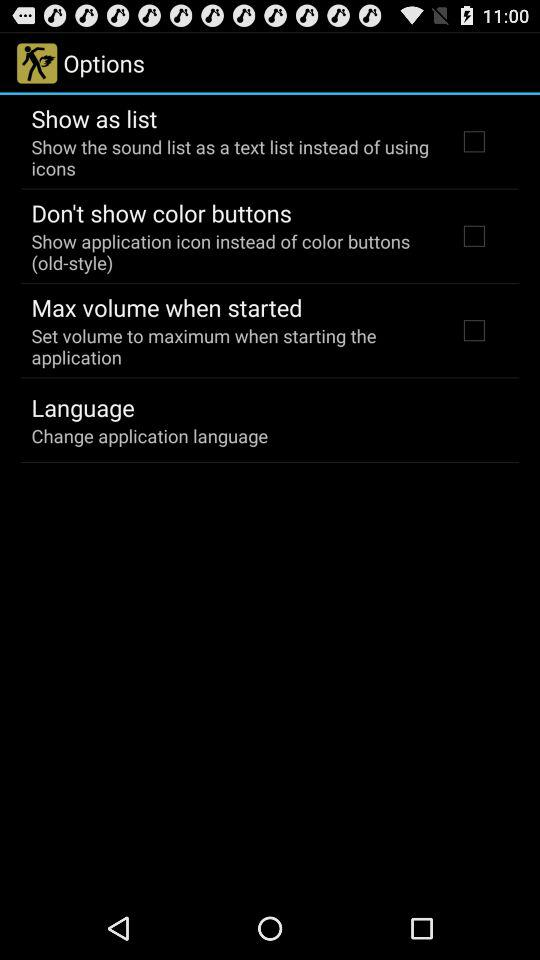What is the chosen application language?
When the provided information is insufficient, respond with <no answer>. <no answer> 